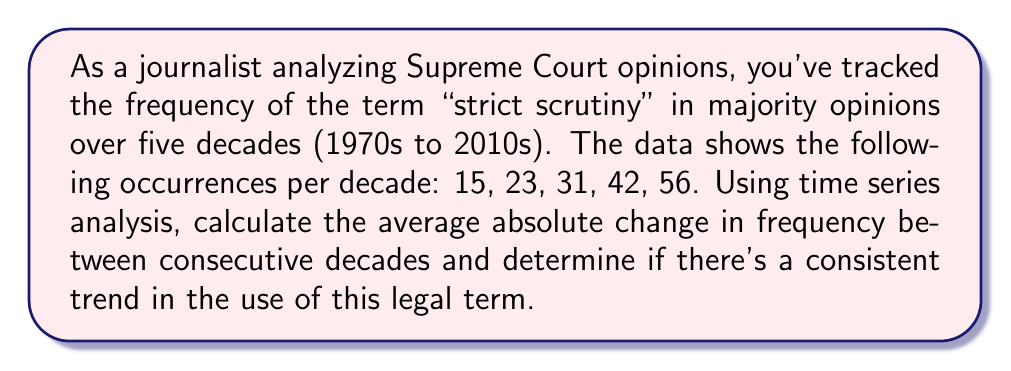Give your solution to this math problem. To solve this problem, we'll follow these steps:

1) Calculate the changes between consecutive decades:
   1980s - 1970s: 23 - 15 = 8
   1990s - 1980s: 31 - 23 = 8
   2000s - 1990s: 42 - 31 = 11
   2010s - 2000s: 56 - 42 = 14

2) Calculate the absolute values of these changes:
   |8|, |8|, |11|, |14|

3) Calculate the average of these absolute changes:
   $$\text{Average Absolute Change} = \frac{\sum_{i=1}^{n} |x_i - x_{i-1}|}{n-1}$$
   
   Where $x_i$ represents the frequency in decade $i$, and $n$ is the number of decades.

   $$\text{Average Absolute Change} = \frac{|8| + |8| + |11| + |14|}{4} = \frac{41}{4} = 10.25$$

4) To determine if there's a consistent trend, we look at the direction of changes:
   All changes are positive, indicating an increasing trend.
   
   We can also calculate the rate of change:
   1970s to 1980s: (23 - 15) / 15 ≈ 53.33% increase
   1980s to 1990s: (31 - 23) / 23 ≈ 34.78% increase
   1990s to 2000s: (42 - 31) / 31 ≈ 35.48% increase
   2000s to 2010s: (56 - 42) / 42 ≈ 33.33% increase

   The rate of increase is relatively consistent after the first interval, hovering around 33-35%.
Answer: The average absolute change in frequency between consecutive decades is 10.25. There is a consistent increasing trend in the use of the term "strict scrutiny", with the frequency increasing by approximately 33-35% each decade after the 1980s. 